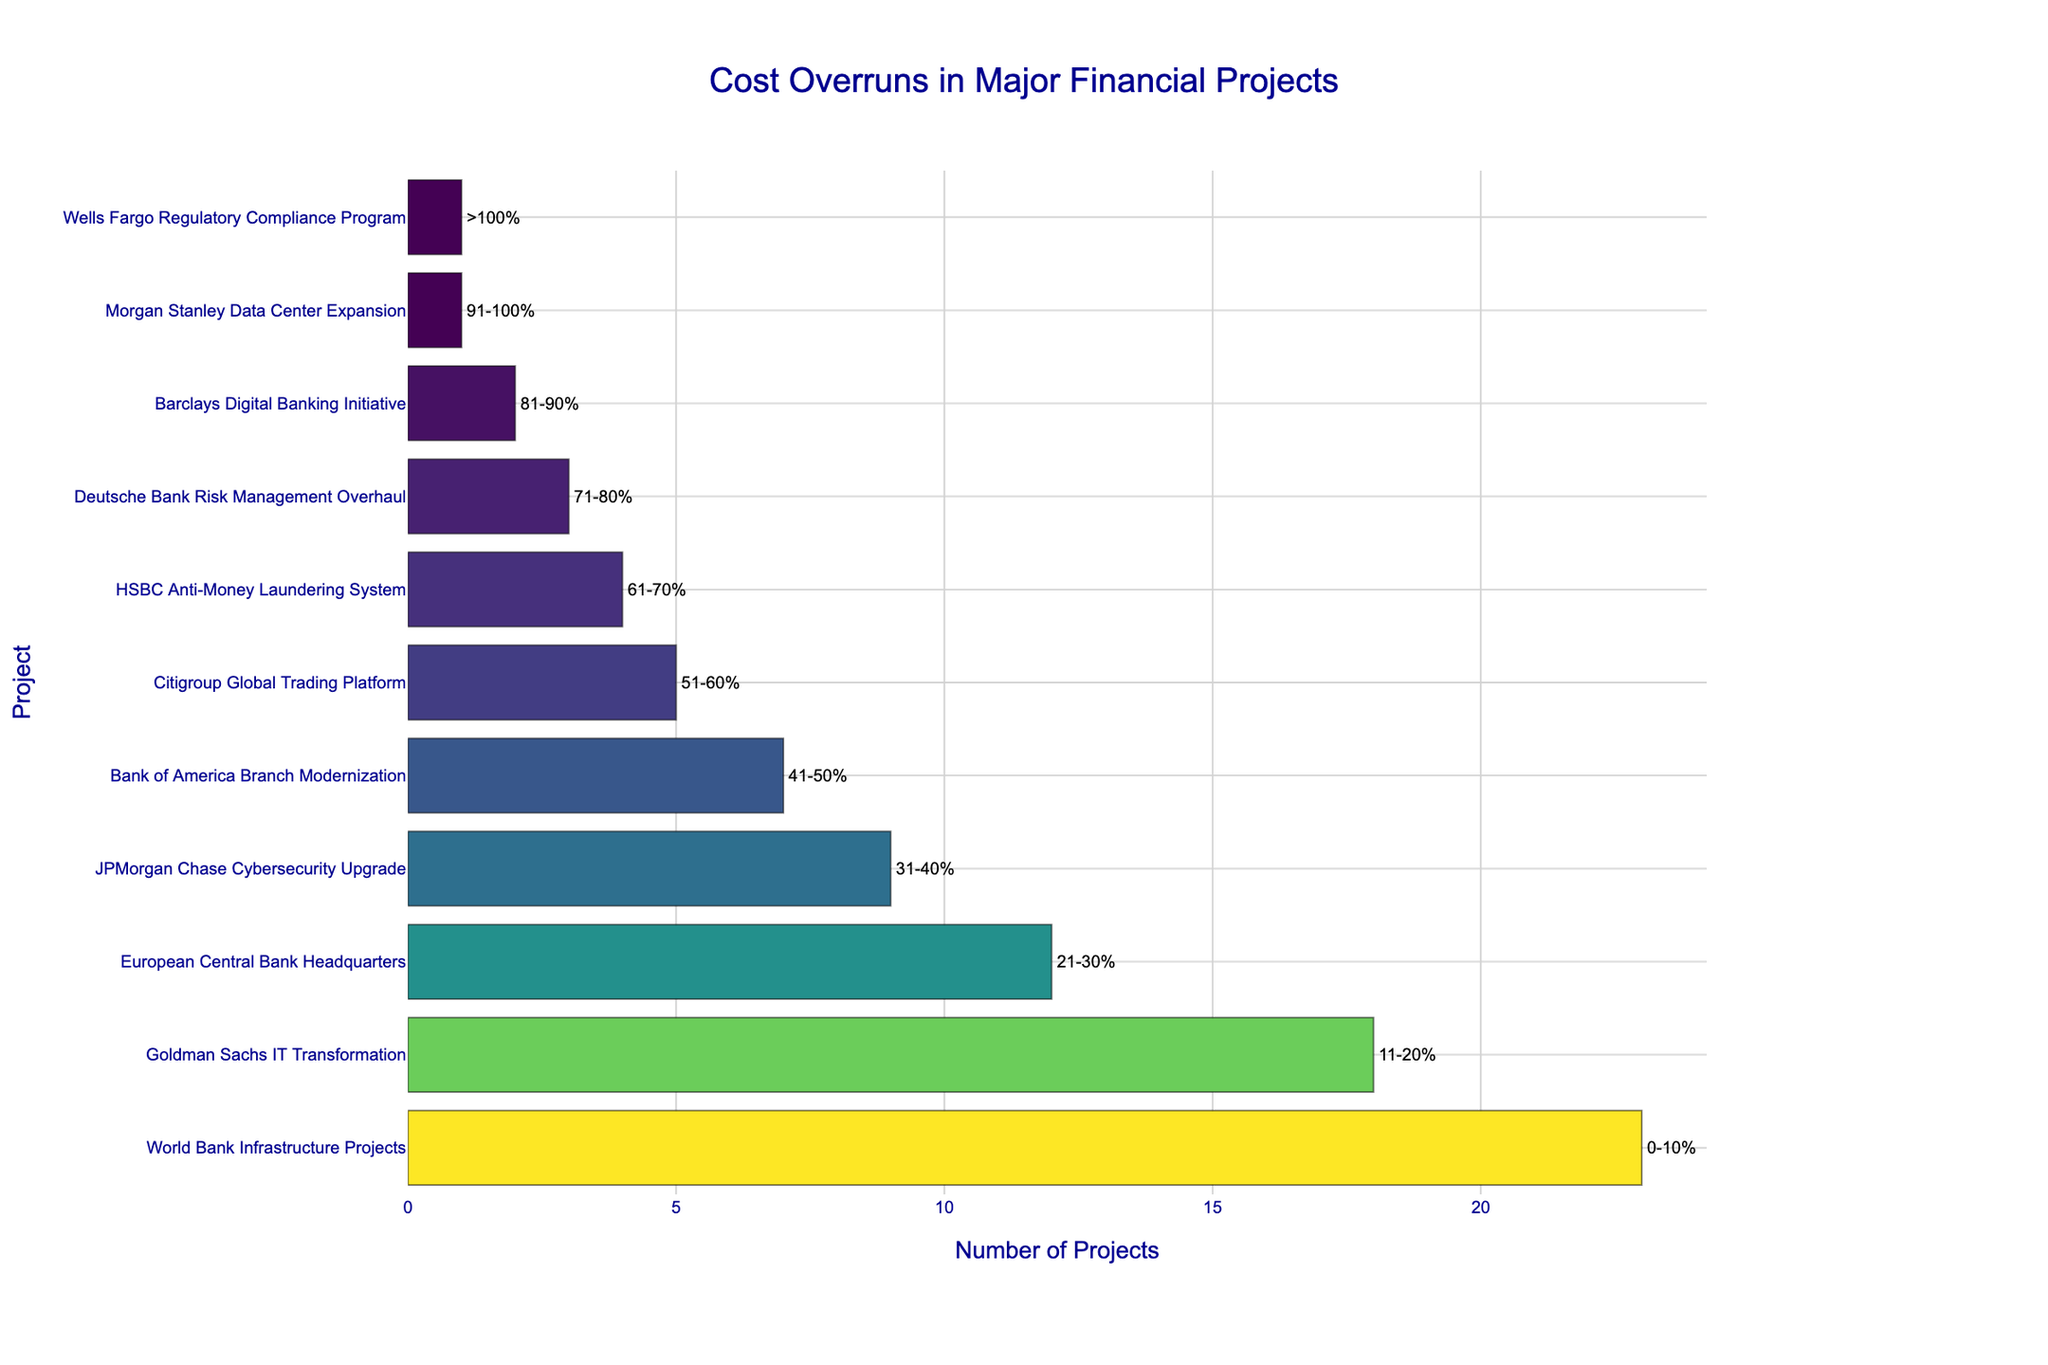What project has the highest number of projects with cost overruns? From the figure, the tallest bar represents the World Bank Infrastructure Projects with 23 projects.
Answer: World Bank Infrastructure Projects Which project falls in the 21-30% cost overrun range? The figure indicates that the European Central Bank Headquarters is associated with a 21-30% cost overrun.
Answer: European Central Bank Headquarters Are there more projects in the 0-10% cost overrun range or the 11-20% range? There are 23 projects in the 0-10% range (World Bank Infrastructure Projects) and 18 projects in the 11-20% range (Goldman Sachs IT Transformation). Hence, there are more projects in the 0-10% range.
Answer: 0-10% Which project has the fewest number of cost overruns? The shortest bars in the figure represent Morgan Stanley Data Center Expansion and Wells Fargo Regulatory Compliance Program, both with 1 project each.
Answer: Morgan Stanley Data Center Expansion, Wells Fargo Regulatory Compliance Program How many projects in total have cost overruns of more than 40%? Summing the number of projects for ranges greater than 40%: 41-50% (7), 51-60% (5), 61-70% (4), 71-80% (3), 81-90% (2), 91-100% (1), and >100% (1), we get 7+5+4+3+2+1+1 = 23.
Answer: 23 Which projects have cost overruns in the 31-40% range? The figure shows that the JPMorgan Chase Cybersecurity Upgrade falls into the 31-40% cost overrun range.
Answer: JPMorgan Chase Cybersecurity Upgrade What is the difference in the number of projects between those with 0-10% and those with 51-60% cost overruns? There are 23 projects with 0-10% overruns and 5 projects with 51-60% overruns. The difference is 23 - 5 = 18.
Answer: 18 How many projects have a cost overrun range above 80%? Summing the number of projects in the ranges 81-90%, 91-100%, and >100%: 2 (Barclays Digital Banking Initiative) + 1 (Morgan Stanley Data Center Expansion) + 1 (Wells Fargo Regulatory Compliance Program) = 4.
Answer: 4 Which project has a cost overrun range of 41-50%? The figure shows that the Bank of America Branch Modernization project falls into the 41-50% range.
Answer: Bank of America Branch Modernization 